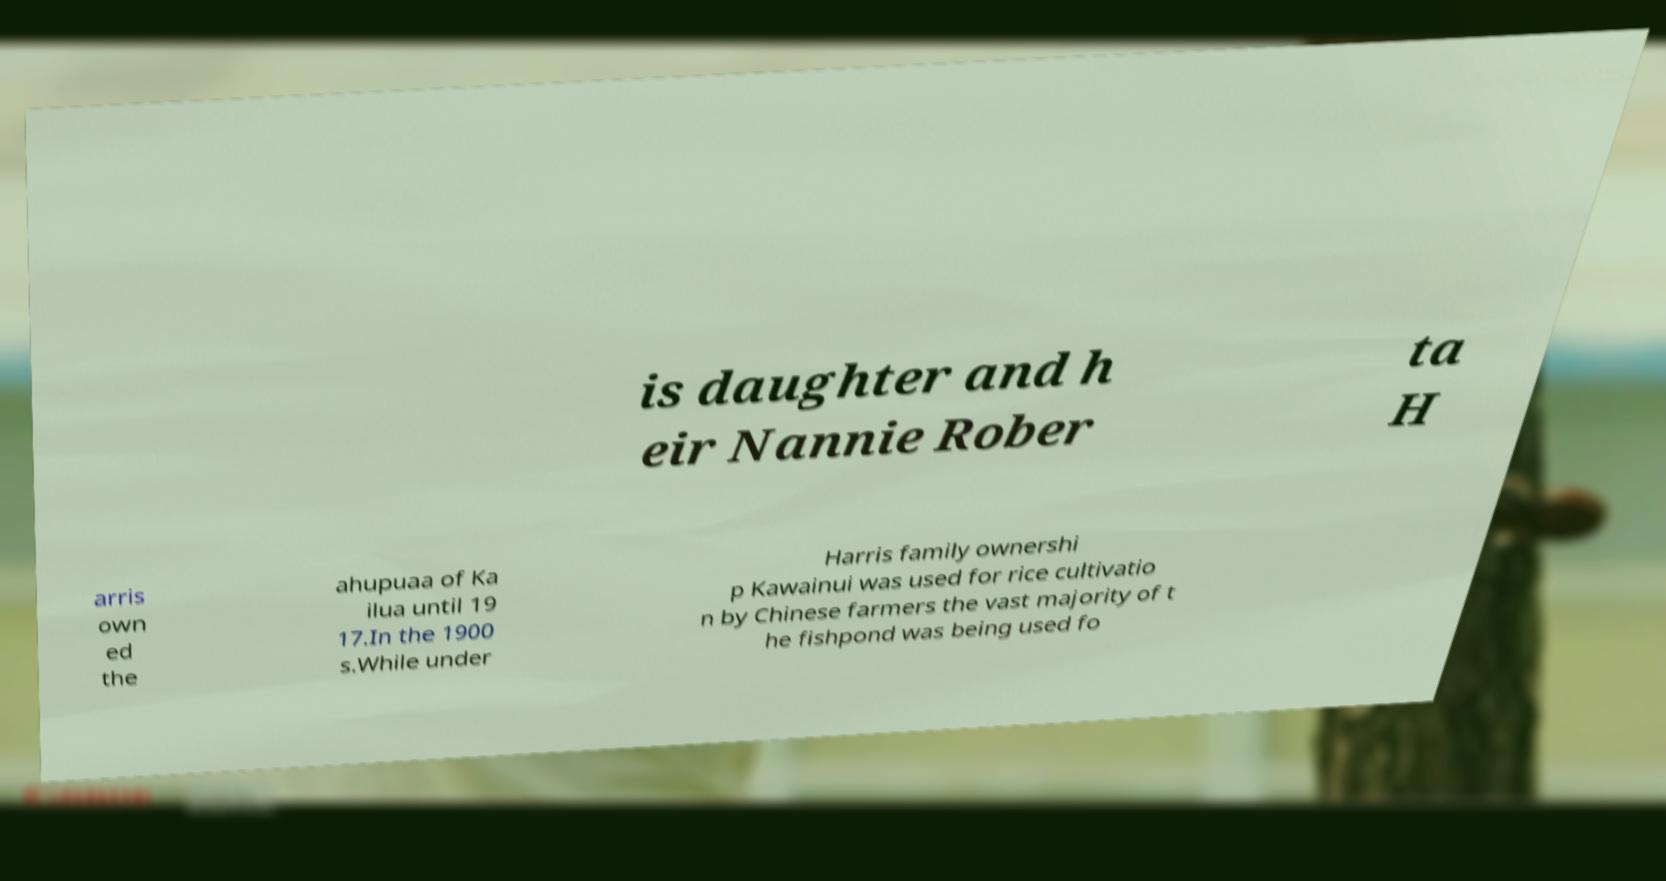I need the written content from this picture converted into text. Can you do that? is daughter and h eir Nannie Rober ta H arris own ed the ahupuaa of Ka ilua until 19 17.In the 1900 s.While under Harris family ownershi p Kawainui was used for rice cultivatio n by Chinese farmers the vast majority of t he fishpond was being used fo 